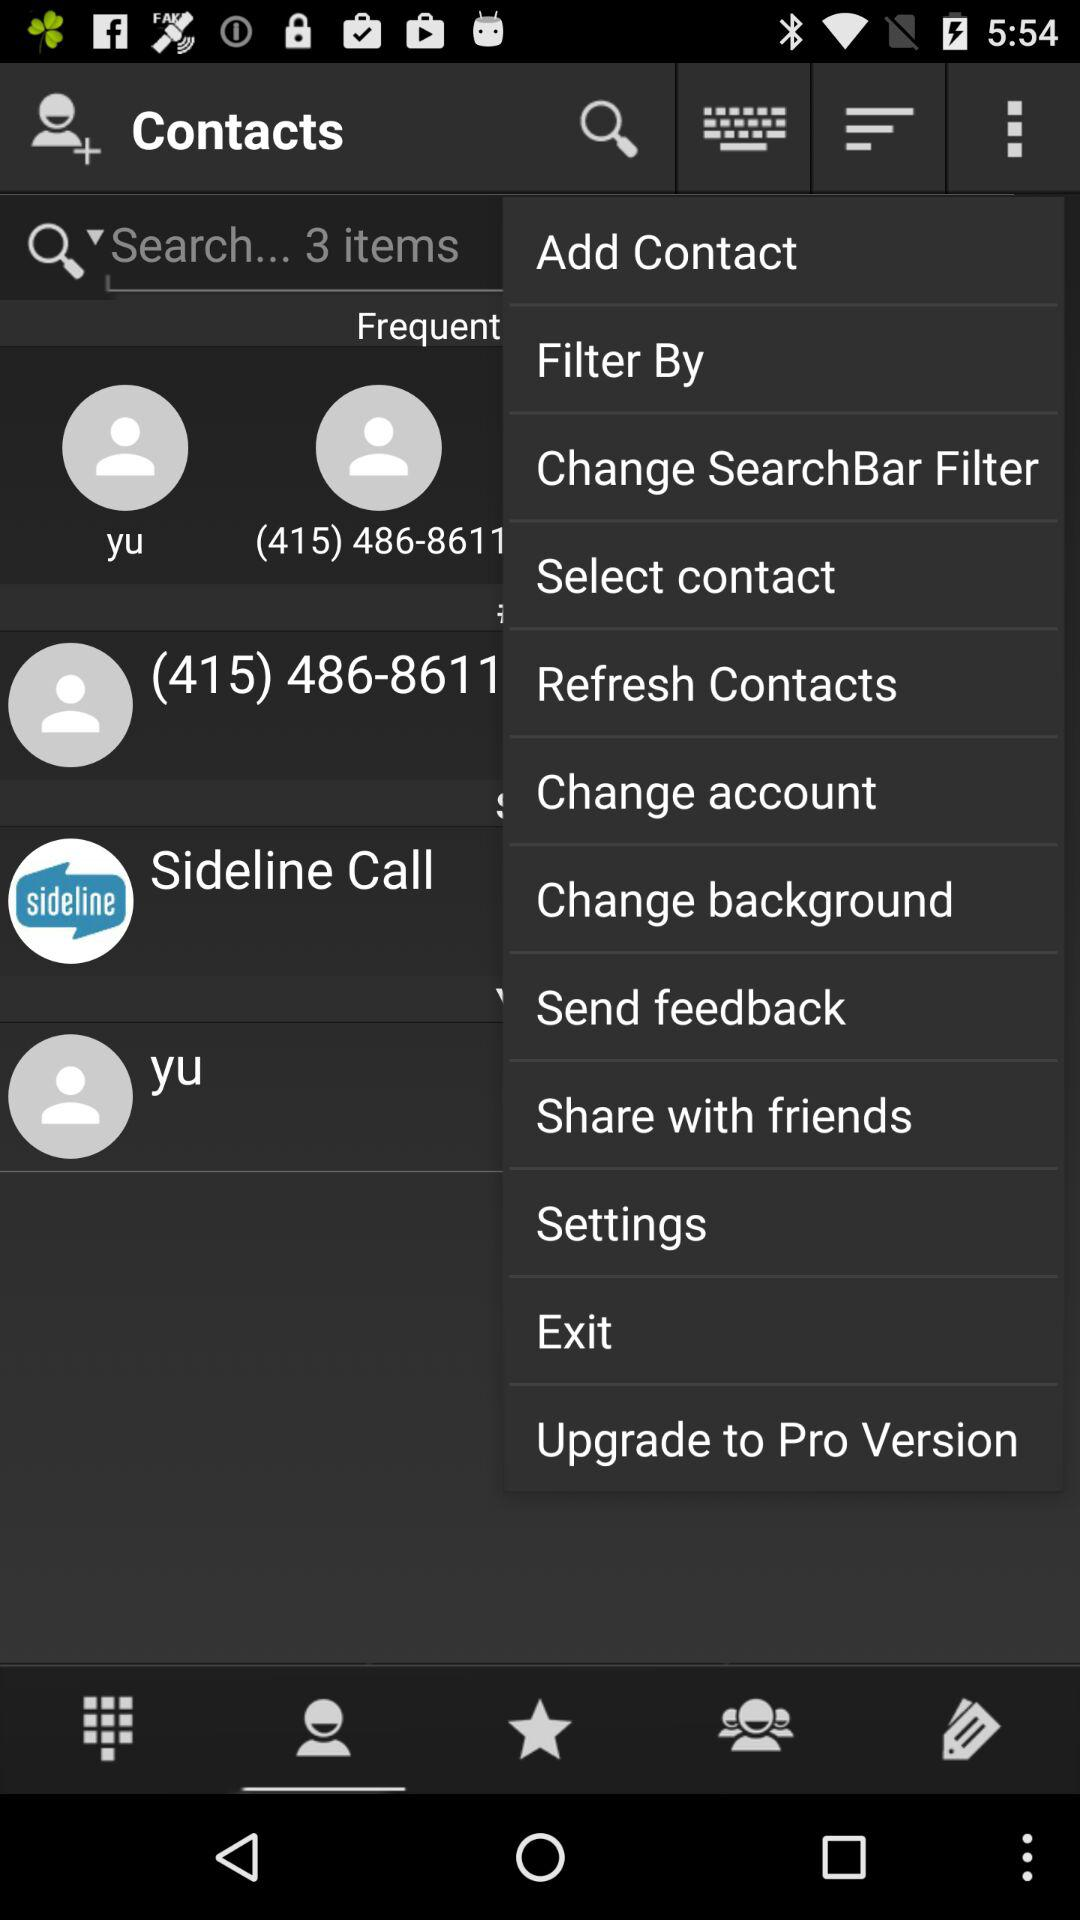What is the status of "Filter By"?
When the provided information is insufficient, respond with <no answer>. <no answer> 